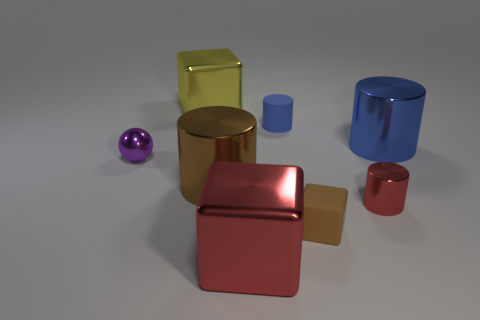What size is the metallic thing that is the same color as the matte cylinder?
Your answer should be very brief. Large. What material is the big cube that is the same color as the tiny metallic cylinder?
Ensure brevity in your answer.  Metal. There is a cylinder that is both in front of the purple object and right of the large red object; what is its material?
Your response must be concise. Metal. Is the number of big blue cylinders in front of the ball the same as the number of red blocks?
Your response must be concise. No. What number of large metal things are the same shape as the small blue object?
Your answer should be very brief. 2. There is a blue thing that is on the right side of the brown block on the left side of the big cylinder behind the shiny ball; how big is it?
Your answer should be very brief. Large. Does the blue thing that is left of the red cylinder have the same material as the yellow object?
Keep it short and to the point. No. Are there an equal number of metallic cylinders in front of the small brown thing and small brown rubber blocks that are behind the purple thing?
Ensure brevity in your answer.  Yes. Is there any other thing that is the same size as the blue metal object?
Offer a terse response. Yes. What is the material of the large blue thing that is the same shape as the small blue rubber object?
Keep it short and to the point. Metal. 